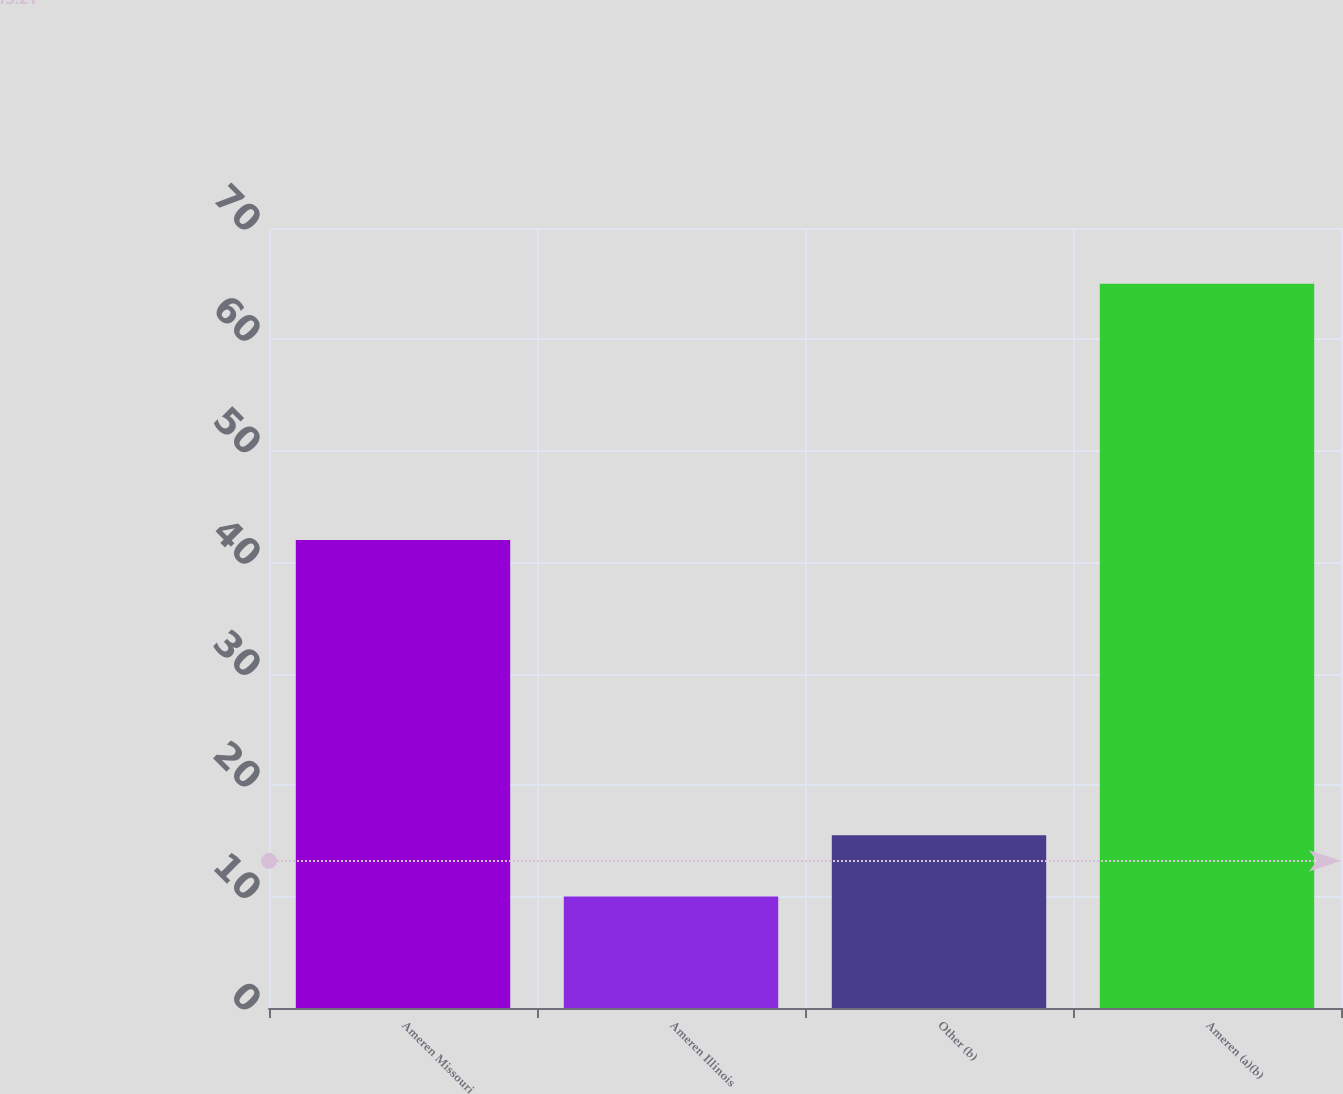Convert chart. <chart><loc_0><loc_0><loc_500><loc_500><bar_chart><fcel>Ameren Missouri<fcel>Ameren Illinois<fcel>Other (b)<fcel>Ameren (a)(b)<nl><fcel>42<fcel>10<fcel>15.5<fcel>65<nl></chart> 